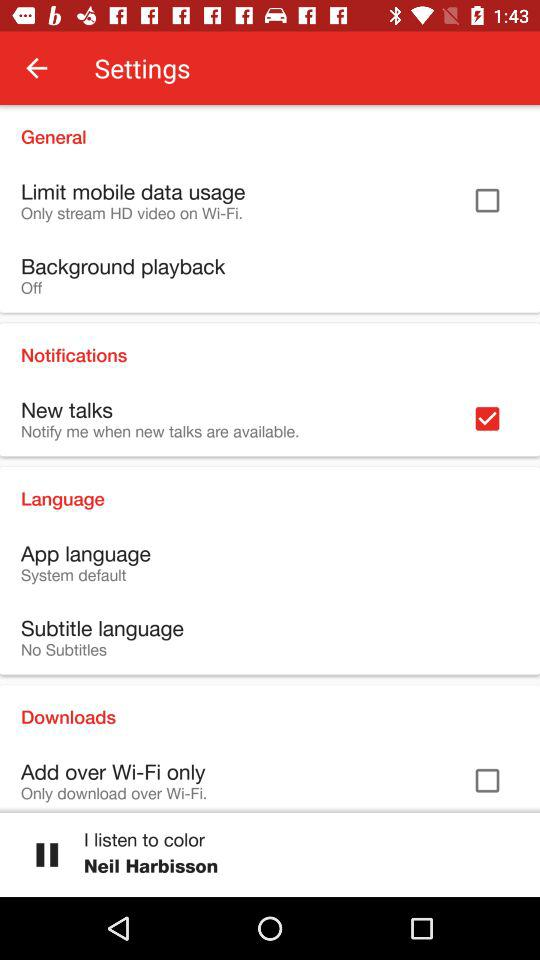What is the current status of "New talks"? The current status of "New talks" is "on". 